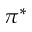Convert formula to latex. <formula><loc_0><loc_0><loc_500><loc_500>\pi ^ { * }</formula> 